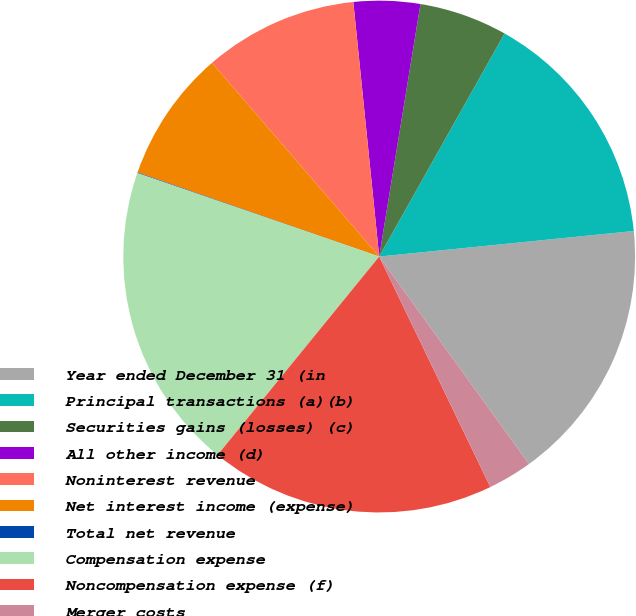<chart> <loc_0><loc_0><loc_500><loc_500><pie_chart><fcel>Year ended December 31 (in<fcel>Principal transactions (a)(b)<fcel>Securities gains (losses) (c)<fcel>All other income (d)<fcel>Noninterest revenue<fcel>Net interest income (expense)<fcel>Total net revenue<fcel>Compensation expense<fcel>Noncompensation expense (f)<fcel>Merger costs<nl><fcel>16.64%<fcel>15.26%<fcel>5.57%<fcel>4.19%<fcel>9.72%<fcel>8.34%<fcel>0.04%<fcel>19.41%<fcel>18.03%<fcel>2.8%<nl></chart> 